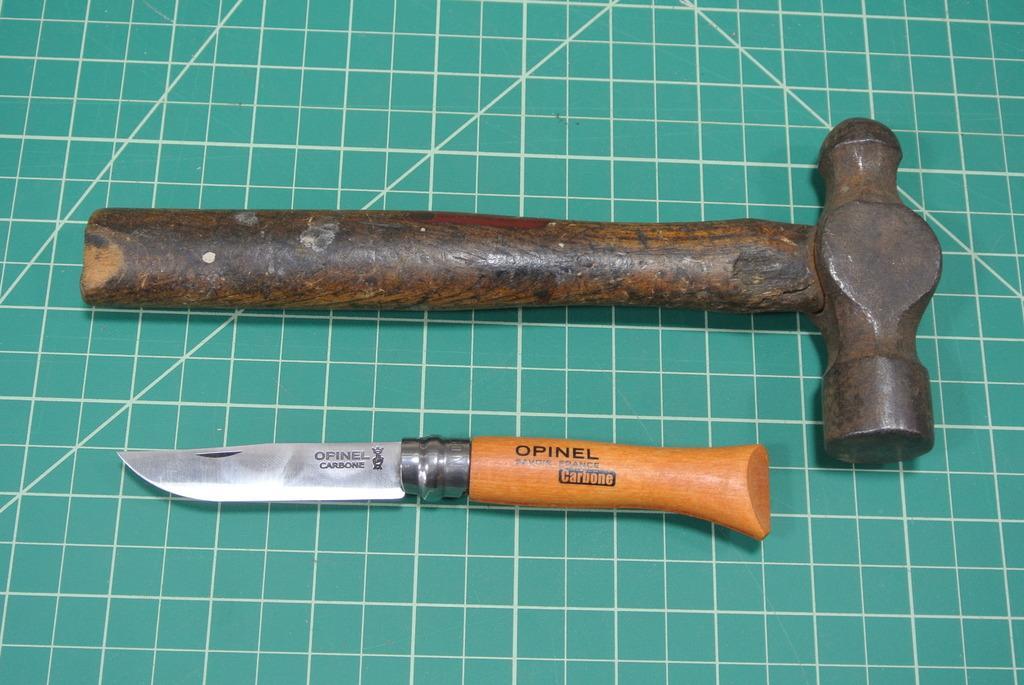Can you describe this image briefly? This picture shows a hammer and a knife on the green color surface. 